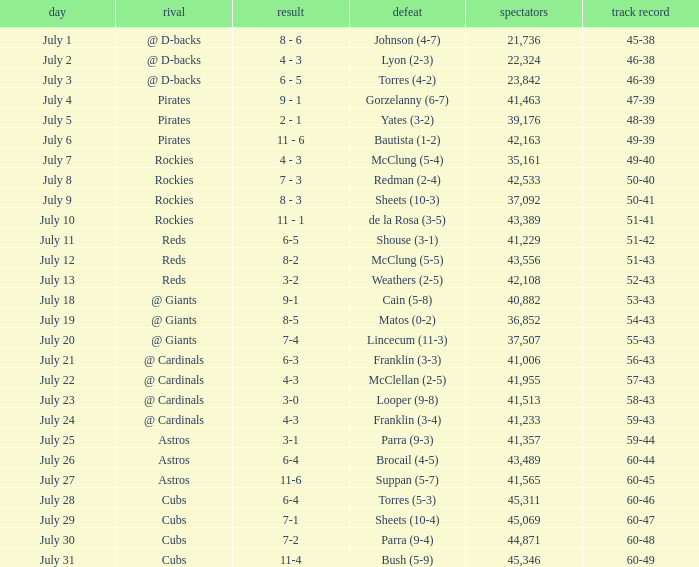What's the attendance of the game where there was a Loss of Yates (3-2)? 39176.0. 